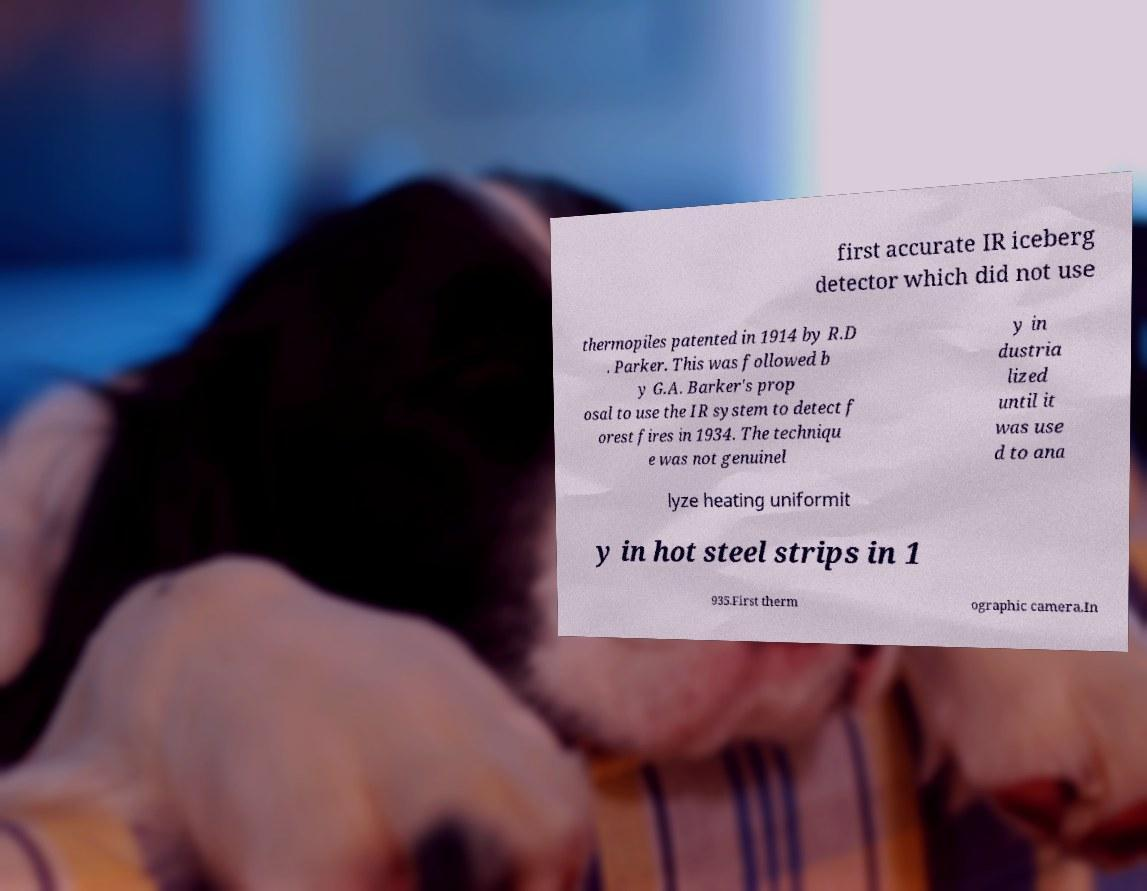Please read and relay the text visible in this image. What does it say? first accurate IR iceberg detector which did not use thermopiles patented in 1914 by R.D . Parker. This was followed b y G.A. Barker's prop osal to use the IR system to detect f orest fires in 1934. The techniqu e was not genuinel y in dustria lized until it was use d to ana lyze heating uniformit y in hot steel strips in 1 935.First therm ographic camera.In 